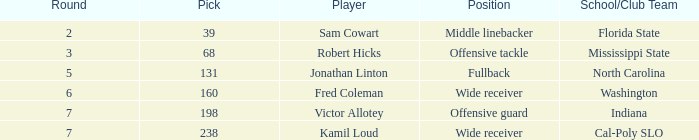Give me the full table as a dictionary. {'header': ['Round', 'Pick', 'Player', 'Position', 'School/Club Team'], 'rows': [['2', '39', 'Sam Cowart', 'Middle linebacker', 'Florida State'], ['3', '68', 'Robert Hicks', 'Offensive tackle', 'Mississippi State'], ['5', '131', 'Jonathan Linton', 'Fullback', 'North Carolina'], ['6', '160', 'Fred Coleman', 'Wide receiver', 'Washington'], ['7', '198', 'Victor Allotey', 'Offensive guard', 'Indiana'], ['7', '238', 'Kamil Loud', 'Wide receiver', 'Cal-Poly SLO']]} Which Round has a School/Club Team of north carolina, and a Pick larger than 131? 0.0. 